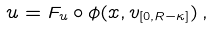Convert formula to latex. <formula><loc_0><loc_0><loc_500><loc_500>u = F _ { u } \circ \phi ( x , v _ { [ 0 , R - \kappa ] } ) \, ,</formula> 